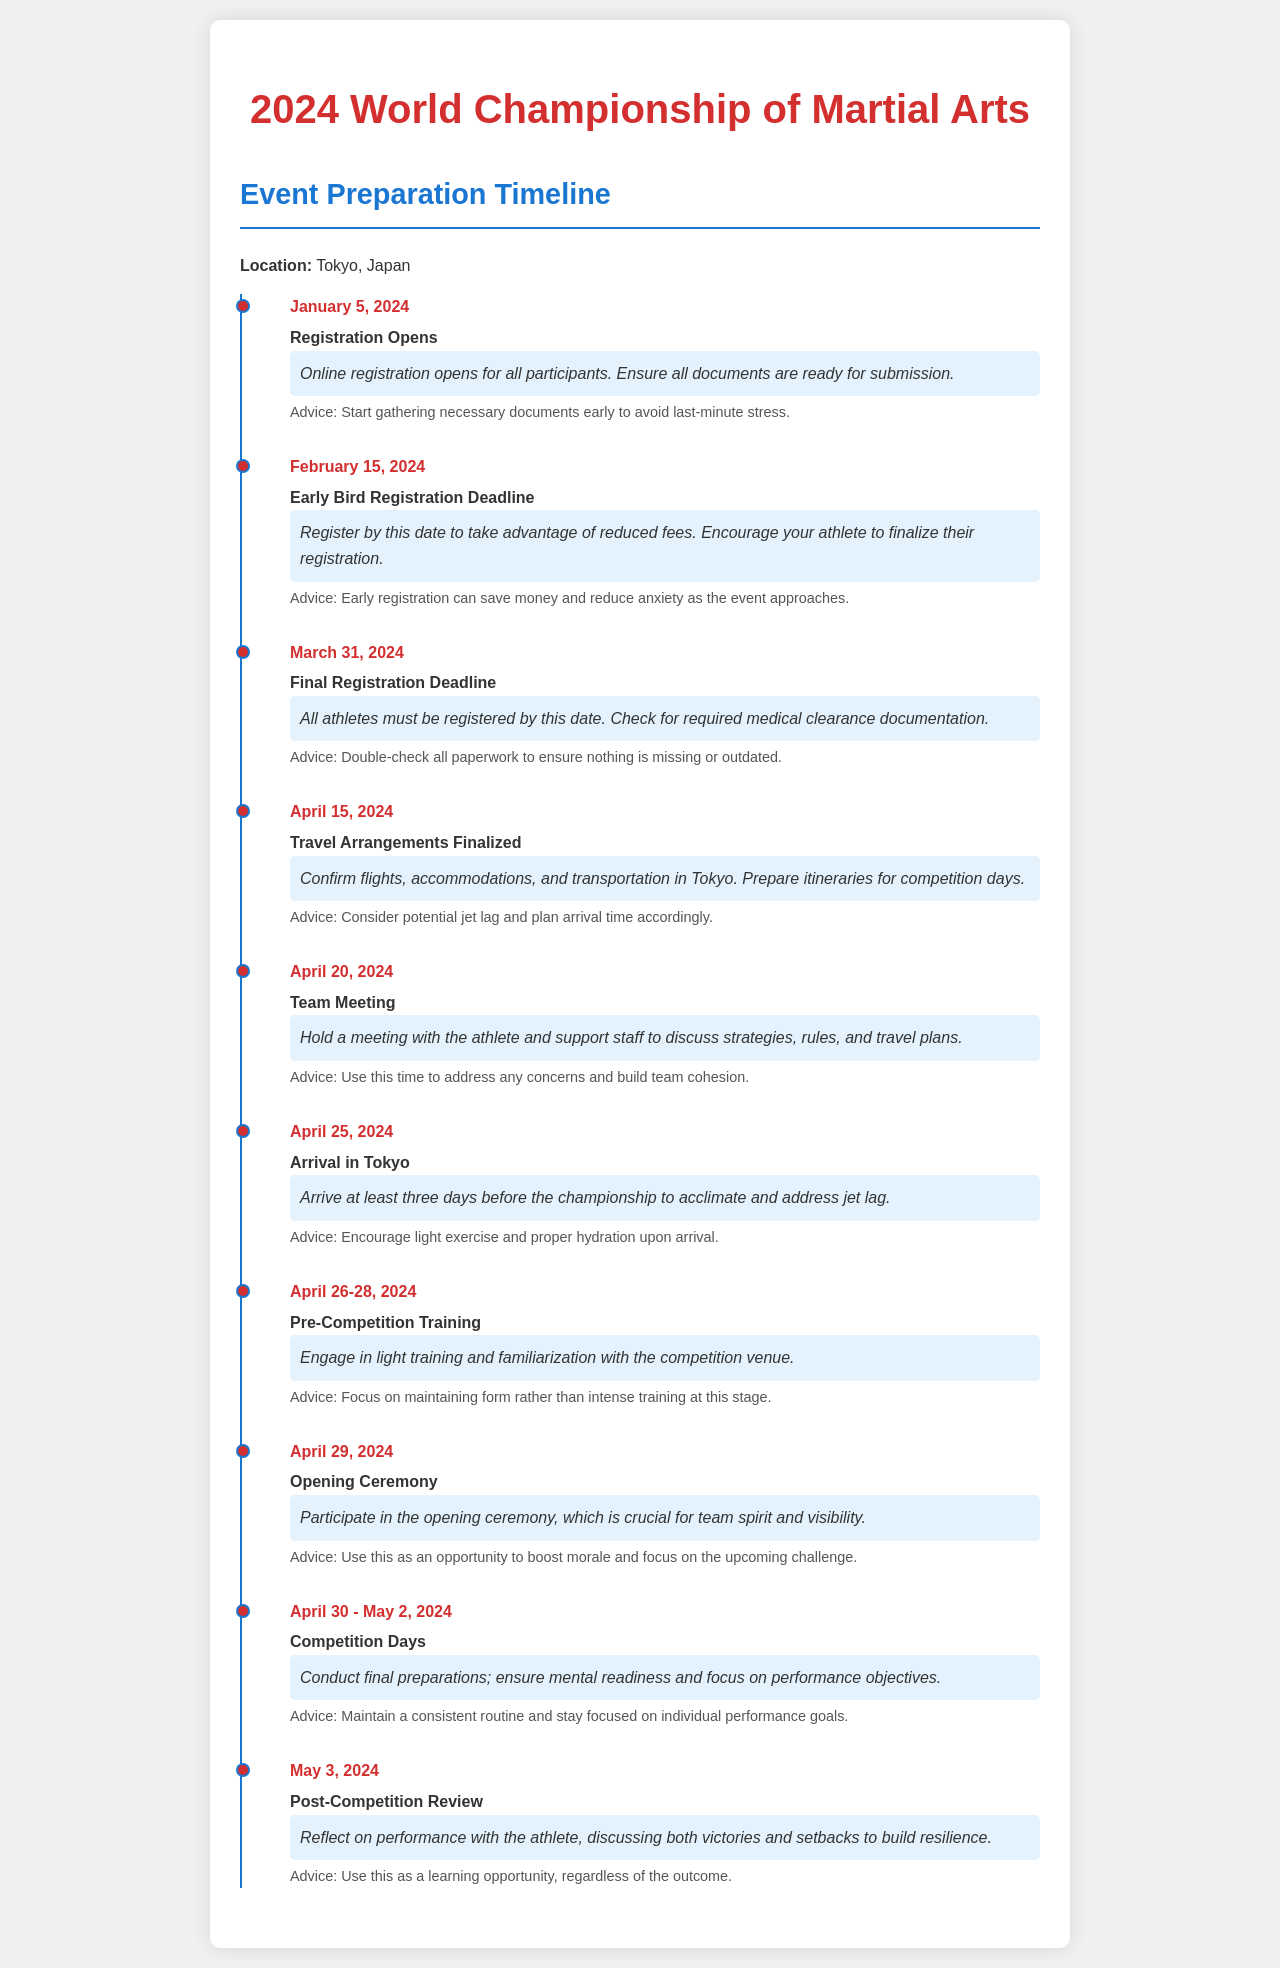What is the event date? The document states that the championship will take place in April 2024, specifically from April 30 to May 2.
Answer: April 30 - May 2, 2024 When does registration open? The document details that online registration opens for all participants on January 5, 2024.
Answer: January 5, 2024 What is the early bird registration deadline? The document specifies that the early bird registration deadline is February 15, 2024.
Answer: February 15, 2024 What should be finalized by April 15, 2024? The document indicates that travel arrangements should be finalized by this date.
Answer: Travel arrangements What advice is given for the team meeting on April 20? The document suggests using the team meeting to address concerns and build cohesion.
Answer: Address concerns and build cohesion How many days before the championship should the team arrive in Tokyo? The document states that the team should arrive at least three days before the championship.
Answer: Three days What are the competition days according to the timeline? The document mentions the competition days as the period from April 30 to May 2, 2024.
Answer: April 30 - May 2, 2024 What is the purpose of the post-competition review? The document describes that the purpose is to discuss both victories and setbacks to build resilience.
Answer: Build resilience What is the location of the championship? The document clearly states that the event will take place in Tokyo, Japan.
Answer: Tokyo, Japan 